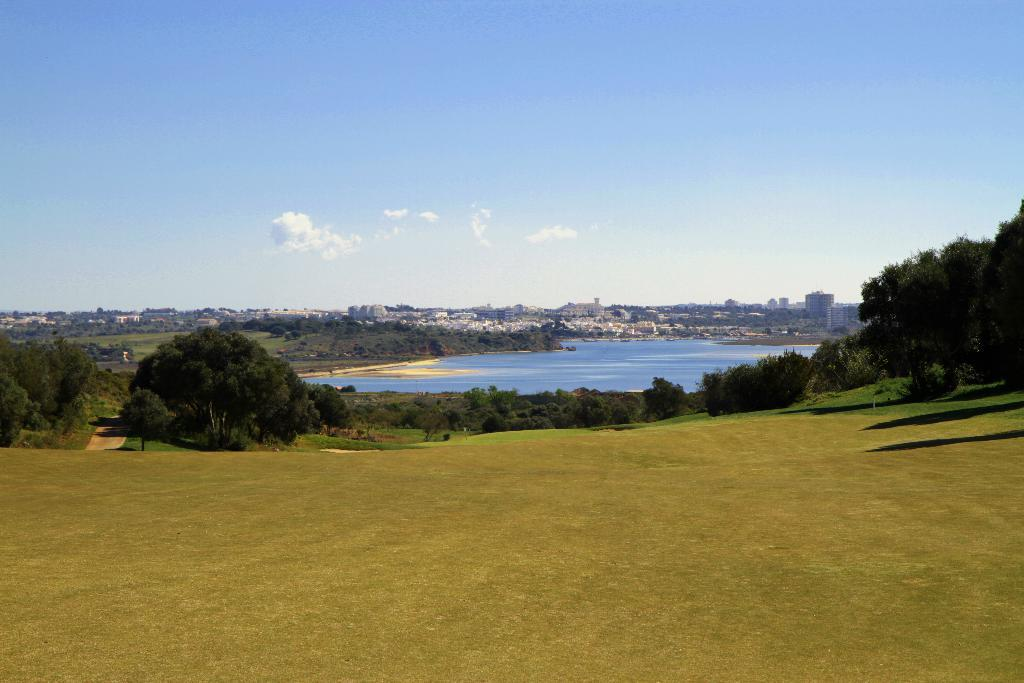What type of vegetation is present on the ground in the image? There is grass on the ground in the image. What other natural elements can be seen in the image? There are trees and water visible in the image. What can be seen in the background of the image? There are buildings, more trees, and clouds in the sky in the background of the image. Can you hear the sound of a boat in the image? There is no boat present in the image, so it is not possible to hear any associated sounds. What type of scale is used to measure the size of the clouds in the image? There is no scale present in the image, and the size of the clouds cannot be measured. 